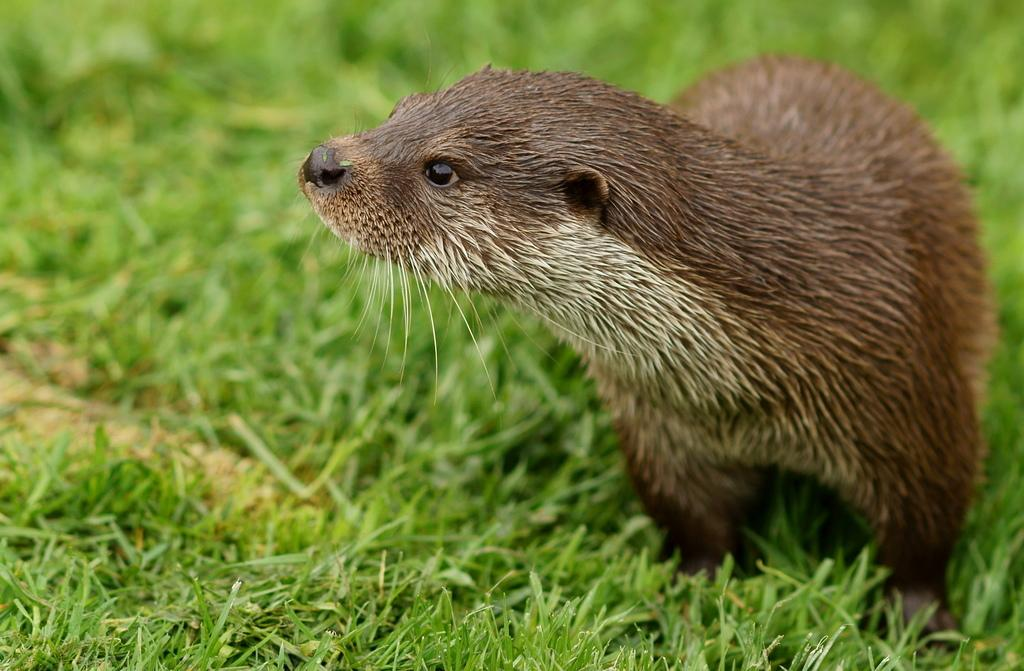What type of animal is in the image? The type of animal cannot be determined from the provided facts. What is the animal standing on or near in the image? The animal is standing on or near grass in the image. How does the animal show respect to the car in the image? There is no car present in the image, so the animal cannot show respect to a car. 